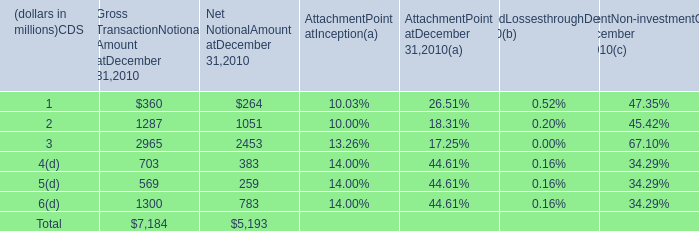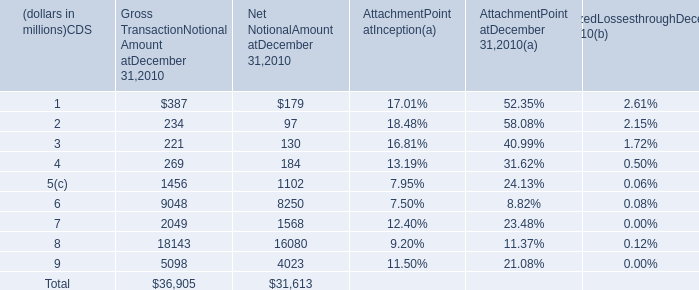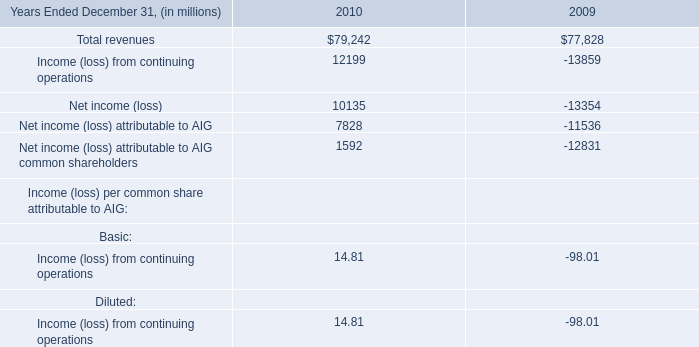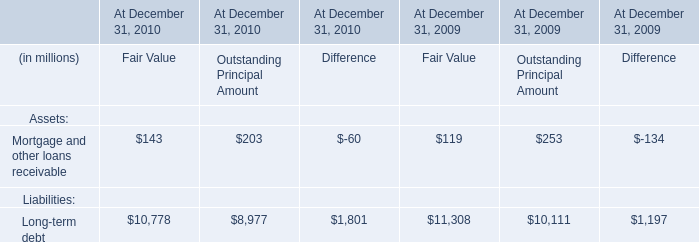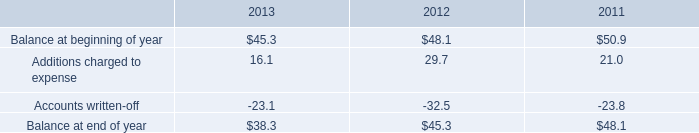as of december 31 , 2013 what was the ratio of the restricted cash and marketable securities to the balance in the allowance for doubtful accounts 
Computations: (169.7 / 38.3)
Answer: 4.43081. 